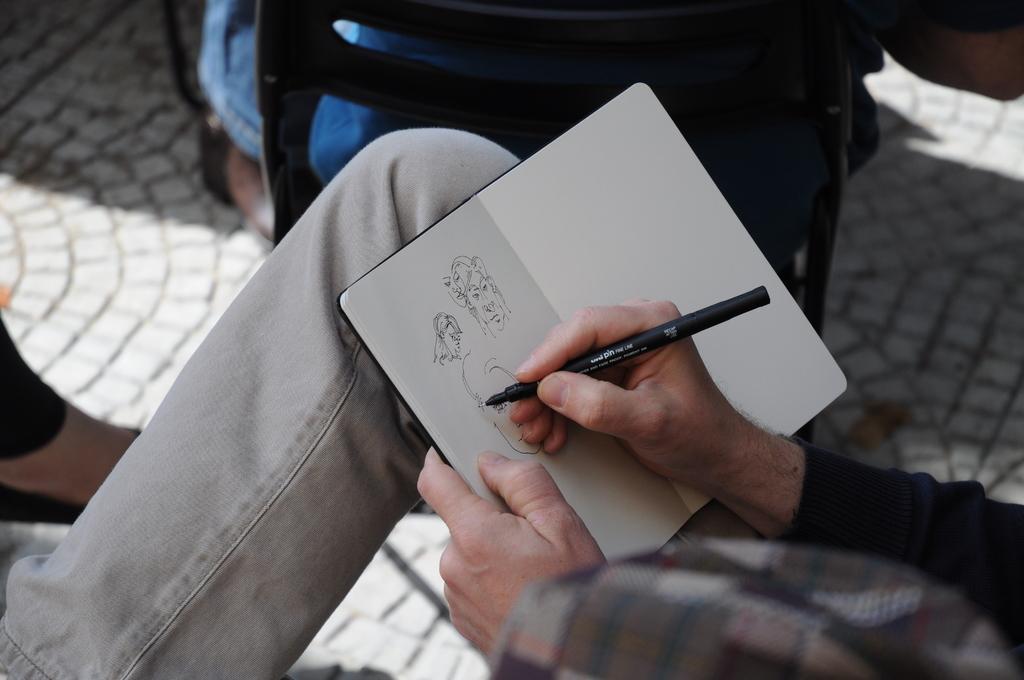Could you give a brief overview of what you see in this image? In this picture we can see people on the ground and one person is holding a book, pen. 